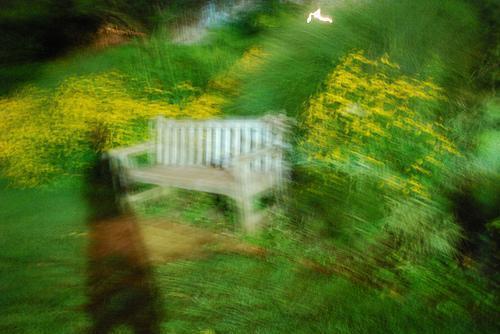How many benches are in the photo?
Give a very brief answer. 1. 